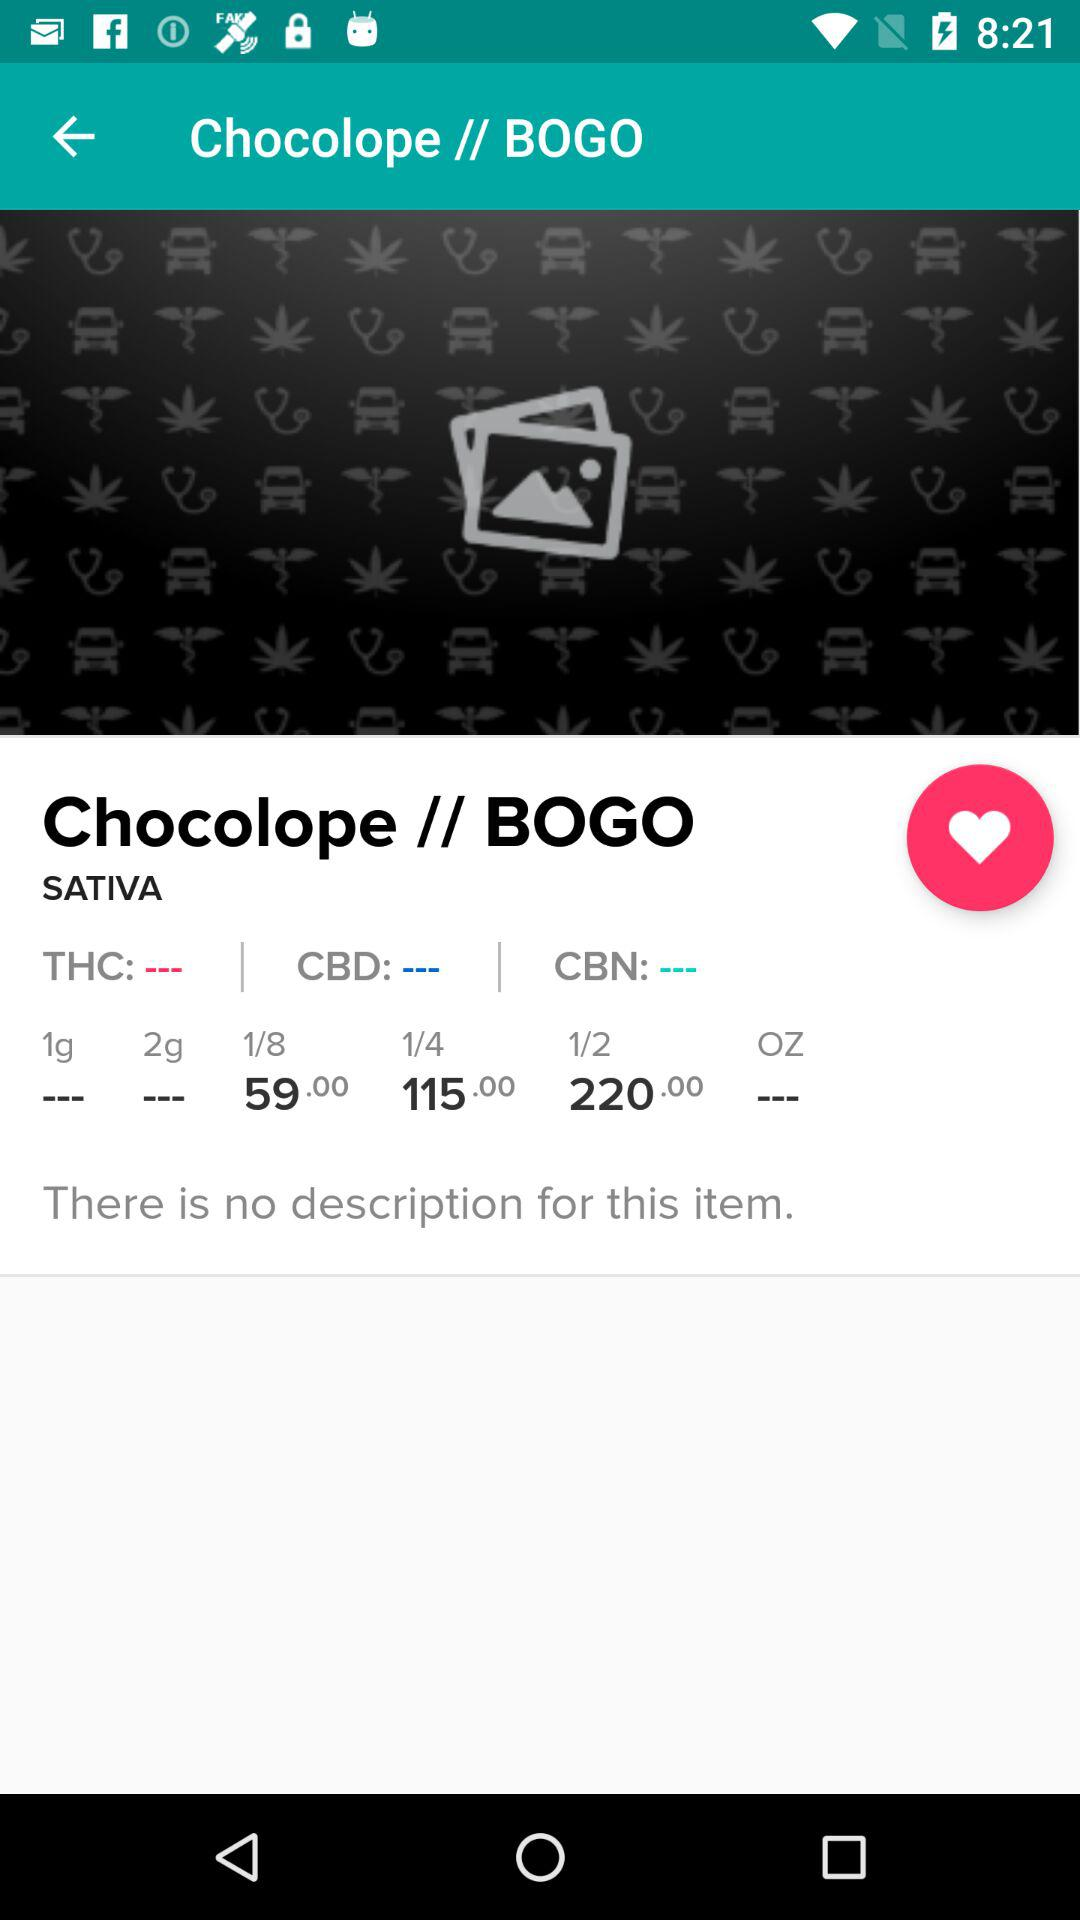How many different sizes of marijuana are available?
Answer the question using a single word or phrase. 6 